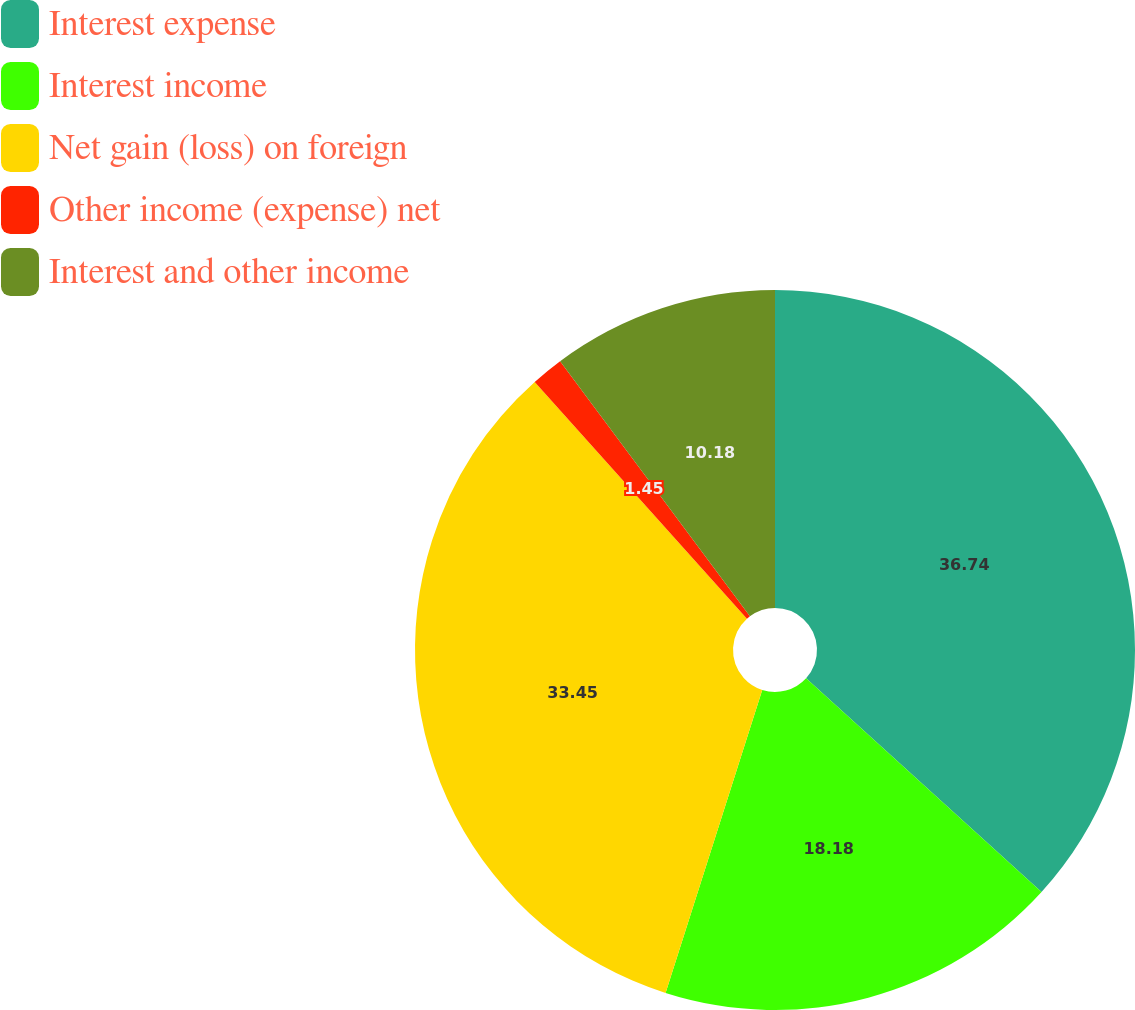Convert chart. <chart><loc_0><loc_0><loc_500><loc_500><pie_chart><fcel>Interest expense<fcel>Interest income<fcel>Net gain (loss) on foreign<fcel>Other income (expense) net<fcel>Interest and other income<nl><fcel>36.73%<fcel>18.18%<fcel>33.45%<fcel>1.45%<fcel>10.18%<nl></chart> 